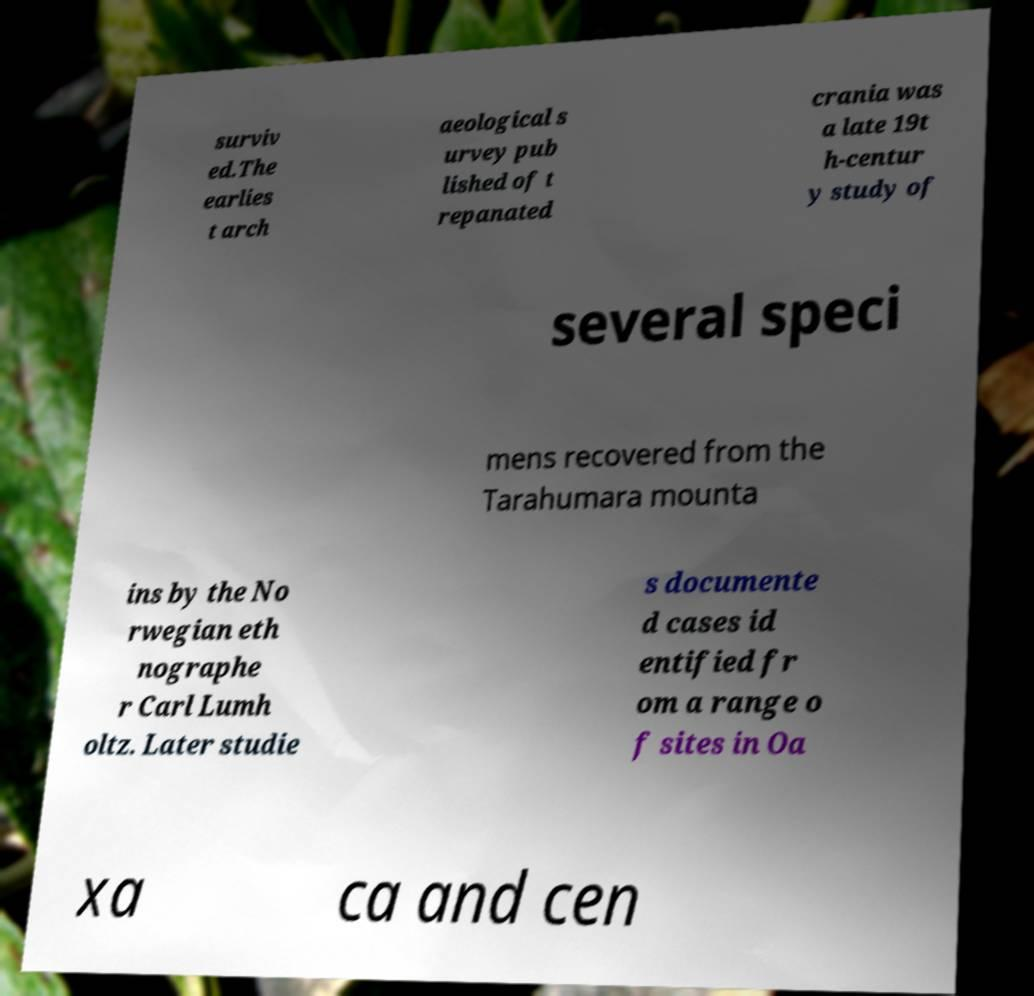Please read and relay the text visible in this image. What does it say? surviv ed.The earlies t arch aeological s urvey pub lished of t repanated crania was a late 19t h-centur y study of several speci mens recovered from the Tarahumara mounta ins by the No rwegian eth nographe r Carl Lumh oltz. Later studie s documente d cases id entified fr om a range o f sites in Oa xa ca and cen 